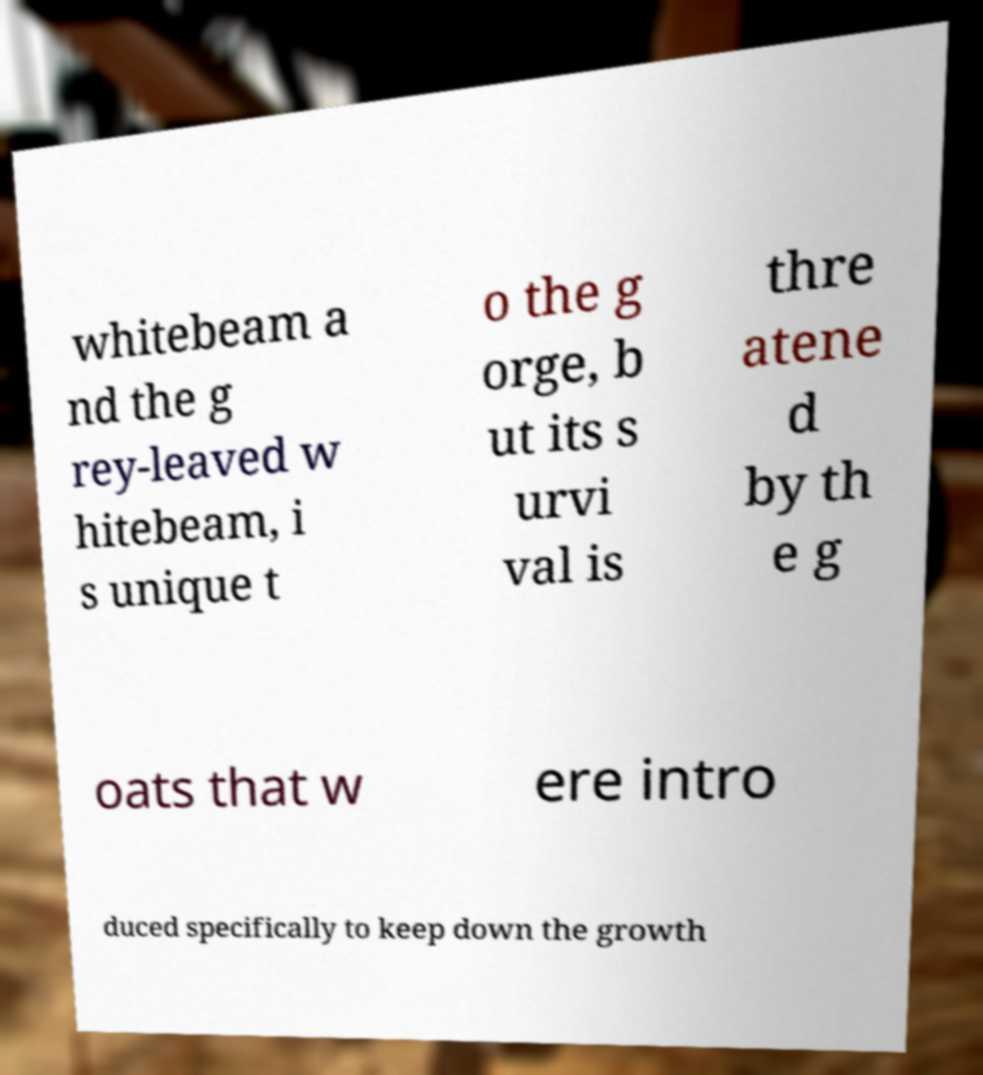What messages or text are displayed in this image? I need them in a readable, typed format. whitebeam a nd the g rey-leaved w hitebeam, i s unique t o the g orge, b ut its s urvi val is thre atene d by th e g oats that w ere intro duced specifically to keep down the growth 